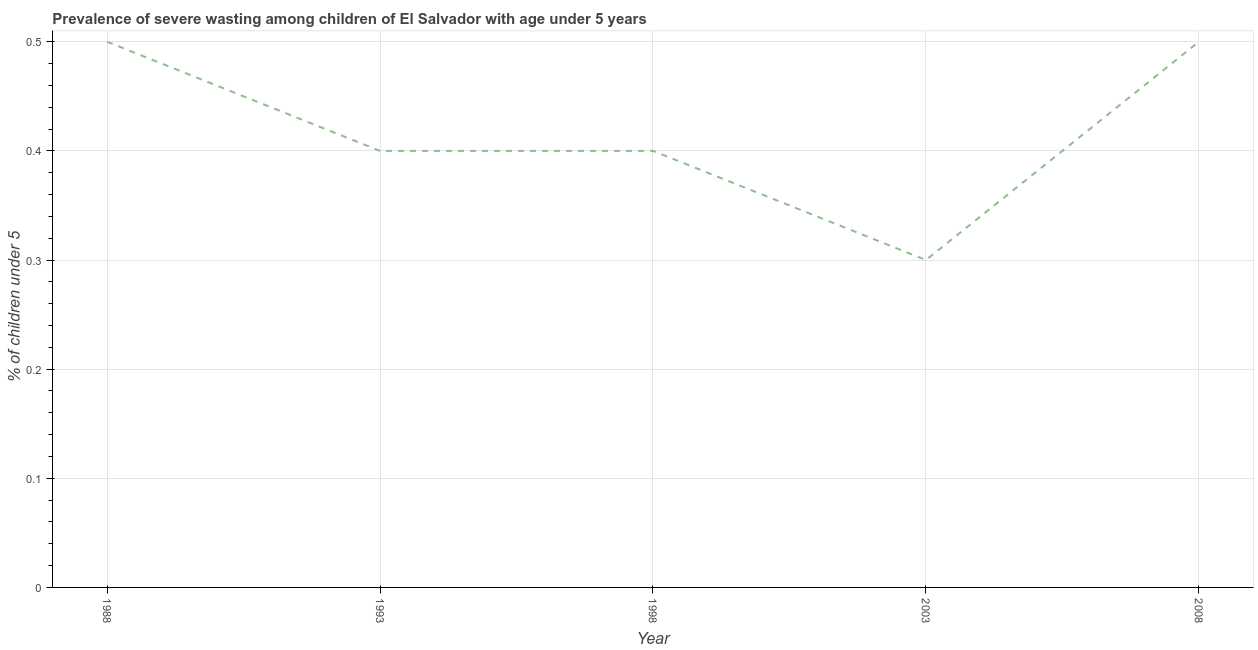What is the prevalence of severe wasting in 2003?
Keep it short and to the point. 0.3. Across all years, what is the minimum prevalence of severe wasting?
Offer a very short reply. 0.3. In which year was the prevalence of severe wasting maximum?
Make the answer very short. 1988. In which year was the prevalence of severe wasting minimum?
Offer a very short reply. 2003. What is the sum of the prevalence of severe wasting?
Your answer should be very brief. 2.1. What is the difference between the prevalence of severe wasting in 1993 and 1998?
Give a very brief answer. 0. What is the average prevalence of severe wasting per year?
Ensure brevity in your answer.  0.42. What is the median prevalence of severe wasting?
Your response must be concise. 0.4. In how many years, is the prevalence of severe wasting greater than 0.08 %?
Your answer should be very brief. 5. Do a majority of the years between 1993 and 2008 (inclusive) have prevalence of severe wasting greater than 0.08 %?
Keep it short and to the point. Yes. What is the ratio of the prevalence of severe wasting in 1988 to that in 1993?
Give a very brief answer. 1.25. Is the sum of the prevalence of severe wasting in 2003 and 2008 greater than the maximum prevalence of severe wasting across all years?
Your answer should be very brief. Yes. What is the difference between the highest and the lowest prevalence of severe wasting?
Your answer should be very brief. 0.2. How many lines are there?
Your answer should be compact. 1. How many years are there in the graph?
Provide a short and direct response. 5. What is the difference between two consecutive major ticks on the Y-axis?
Ensure brevity in your answer.  0.1. Does the graph contain any zero values?
Make the answer very short. No. Does the graph contain grids?
Your answer should be compact. Yes. What is the title of the graph?
Your answer should be compact. Prevalence of severe wasting among children of El Salvador with age under 5 years. What is the label or title of the X-axis?
Your answer should be compact. Year. What is the label or title of the Y-axis?
Ensure brevity in your answer.   % of children under 5. What is the  % of children under 5 in 1988?
Give a very brief answer. 0.5. What is the  % of children under 5 of 1993?
Your response must be concise. 0.4. What is the  % of children under 5 in 1998?
Offer a very short reply. 0.4. What is the  % of children under 5 of 2003?
Your answer should be very brief. 0.3. What is the difference between the  % of children under 5 in 1988 and 2003?
Your answer should be very brief. 0.2. What is the difference between the  % of children under 5 in 1988 and 2008?
Provide a succinct answer. 0. What is the difference between the  % of children under 5 in 1993 and 2003?
Offer a very short reply. 0.1. What is the difference between the  % of children under 5 in 1998 and 2008?
Your answer should be compact. -0.1. What is the difference between the  % of children under 5 in 2003 and 2008?
Your response must be concise. -0.2. What is the ratio of the  % of children under 5 in 1988 to that in 1993?
Provide a short and direct response. 1.25. What is the ratio of the  % of children under 5 in 1988 to that in 2003?
Your answer should be very brief. 1.67. What is the ratio of the  % of children under 5 in 1993 to that in 1998?
Your answer should be compact. 1. What is the ratio of the  % of children under 5 in 1993 to that in 2003?
Provide a succinct answer. 1.33. What is the ratio of the  % of children under 5 in 1998 to that in 2003?
Provide a short and direct response. 1.33. What is the ratio of the  % of children under 5 in 2003 to that in 2008?
Make the answer very short. 0.6. 